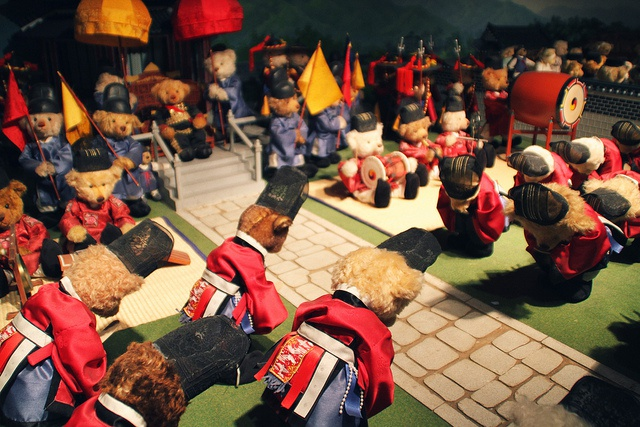Describe the objects in this image and their specific colors. I can see teddy bear in black, maroon, tan, and gray tones, teddy bear in black, red, and tan tones, teddy bear in black, salmon, red, and brown tones, teddy bear in black, maroon, orange, and brown tones, and teddy bear in black, orange, brown, and red tones in this image. 